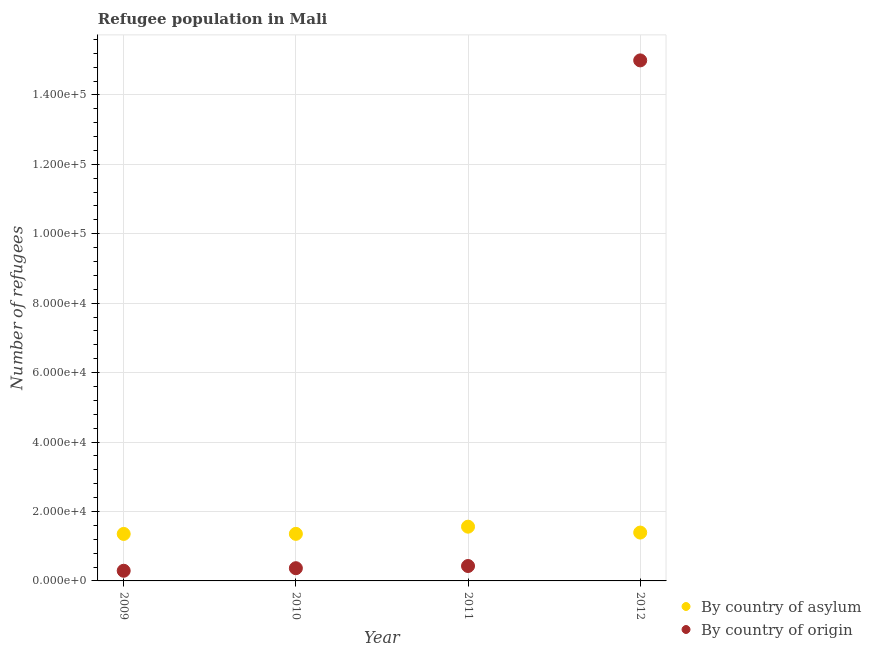How many different coloured dotlines are there?
Your response must be concise. 2. What is the number of refugees by country of asylum in 2010?
Keep it short and to the point. 1.36e+04. Across all years, what is the maximum number of refugees by country of origin?
Ensure brevity in your answer.  1.50e+05. Across all years, what is the minimum number of refugees by country of origin?
Your response must be concise. 2926. In which year was the number of refugees by country of origin maximum?
Provide a succinct answer. 2012. In which year was the number of refugees by country of origin minimum?
Make the answer very short. 2009. What is the total number of refugees by country of origin in the graph?
Provide a short and direct response. 1.61e+05. What is the difference between the number of refugees by country of origin in 2010 and that in 2012?
Keep it short and to the point. -1.46e+05. What is the difference between the number of refugees by country of asylum in 2011 and the number of refugees by country of origin in 2012?
Your answer should be very brief. -1.34e+05. What is the average number of refugees by country of origin per year?
Make the answer very short. 4.02e+04. In the year 2011, what is the difference between the number of refugees by country of origin and number of refugees by country of asylum?
Make the answer very short. -1.13e+04. In how many years, is the number of refugees by country of origin greater than 108000?
Offer a terse response. 1. What is the ratio of the number of refugees by country of asylum in 2009 to that in 2011?
Keep it short and to the point. 0.87. Is the difference between the number of refugees by country of asylum in 2011 and 2012 greater than the difference between the number of refugees by country of origin in 2011 and 2012?
Offer a very short reply. Yes. What is the difference between the highest and the second highest number of refugees by country of asylum?
Give a very brief answer. 1696. What is the difference between the highest and the lowest number of refugees by country of asylum?
Keep it short and to the point. 2086. Is the number of refugees by country of origin strictly less than the number of refugees by country of asylum over the years?
Provide a short and direct response. No. What is the difference between two consecutive major ticks on the Y-axis?
Provide a succinct answer. 2.00e+04. Are the values on the major ticks of Y-axis written in scientific E-notation?
Provide a succinct answer. Yes. Does the graph contain any zero values?
Your answer should be compact. No. Does the graph contain grids?
Ensure brevity in your answer.  Yes. How many legend labels are there?
Your answer should be compact. 2. What is the title of the graph?
Offer a very short reply. Refugee population in Mali. Does "Secondary school" appear as one of the legend labels in the graph?
Your answer should be very brief. No. What is the label or title of the Y-axis?
Ensure brevity in your answer.  Number of refugees. What is the Number of refugees in By country of asylum in 2009?
Your answer should be compact. 1.35e+04. What is the Number of refugees of By country of origin in 2009?
Offer a very short reply. 2926. What is the Number of refugees in By country of asylum in 2010?
Ensure brevity in your answer.  1.36e+04. What is the Number of refugees in By country of origin in 2010?
Your answer should be very brief. 3663. What is the Number of refugees of By country of asylum in 2011?
Offer a terse response. 1.56e+04. What is the Number of refugees in By country of origin in 2011?
Your response must be concise. 4295. What is the Number of refugees in By country of asylum in 2012?
Make the answer very short. 1.39e+04. What is the Number of refugees in By country of origin in 2012?
Provide a succinct answer. 1.50e+05. Across all years, what is the maximum Number of refugees in By country of asylum?
Offer a terse response. 1.56e+04. Across all years, what is the maximum Number of refugees in By country of origin?
Provide a succinct answer. 1.50e+05. Across all years, what is the minimum Number of refugees in By country of asylum?
Your answer should be very brief. 1.35e+04. Across all years, what is the minimum Number of refugees in By country of origin?
Make the answer very short. 2926. What is the total Number of refugees of By country of asylum in the graph?
Keep it short and to the point. 5.66e+04. What is the total Number of refugees of By country of origin in the graph?
Your answer should be compact. 1.61e+05. What is the difference between the Number of refugees of By country of origin in 2009 and that in 2010?
Offer a terse response. -737. What is the difference between the Number of refugees in By country of asylum in 2009 and that in 2011?
Make the answer very short. -2086. What is the difference between the Number of refugees in By country of origin in 2009 and that in 2011?
Your response must be concise. -1369. What is the difference between the Number of refugees of By country of asylum in 2009 and that in 2012?
Your answer should be very brief. -390. What is the difference between the Number of refugees in By country of origin in 2009 and that in 2012?
Make the answer very short. -1.47e+05. What is the difference between the Number of refugees of By country of asylum in 2010 and that in 2011?
Offer a terse response. -2066. What is the difference between the Number of refugees of By country of origin in 2010 and that in 2011?
Give a very brief answer. -632. What is the difference between the Number of refugees in By country of asylum in 2010 and that in 2012?
Keep it short and to the point. -370. What is the difference between the Number of refugees in By country of origin in 2010 and that in 2012?
Provide a short and direct response. -1.46e+05. What is the difference between the Number of refugees of By country of asylum in 2011 and that in 2012?
Make the answer very short. 1696. What is the difference between the Number of refugees of By country of origin in 2011 and that in 2012?
Offer a terse response. -1.46e+05. What is the difference between the Number of refugees of By country of asylum in 2009 and the Number of refugees of By country of origin in 2010?
Offer a terse response. 9875. What is the difference between the Number of refugees in By country of asylum in 2009 and the Number of refugees in By country of origin in 2011?
Provide a succinct answer. 9243. What is the difference between the Number of refugees in By country of asylum in 2009 and the Number of refugees in By country of origin in 2012?
Provide a short and direct response. -1.36e+05. What is the difference between the Number of refugees of By country of asylum in 2010 and the Number of refugees of By country of origin in 2011?
Your response must be concise. 9263. What is the difference between the Number of refugees in By country of asylum in 2010 and the Number of refugees in By country of origin in 2012?
Your answer should be compact. -1.36e+05. What is the difference between the Number of refugees in By country of asylum in 2011 and the Number of refugees in By country of origin in 2012?
Your answer should be compact. -1.34e+05. What is the average Number of refugees of By country of asylum per year?
Offer a terse response. 1.42e+04. What is the average Number of refugees in By country of origin per year?
Offer a very short reply. 4.02e+04. In the year 2009, what is the difference between the Number of refugees in By country of asylum and Number of refugees in By country of origin?
Ensure brevity in your answer.  1.06e+04. In the year 2010, what is the difference between the Number of refugees of By country of asylum and Number of refugees of By country of origin?
Your response must be concise. 9895. In the year 2011, what is the difference between the Number of refugees in By country of asylum and Number of refugees in By country of origin?
Make the answer very short. 1.13e+04. In the year 2012, what is the difference between the Number of refugees in By country of asylum and Number of refugees in By country of origin?
Keep it short and to the point. -1.36e+05. What is the ratio of the Number of refugees of By country of asylum in 2009 to that in 2010?
Offer a very short reply. 1. What is the ratio of the Number of refugees of By country of origin in 2009 to that in 2010?
Your answer should be compact. 0.8. What is the ratio of the Number of refugees in By country of asylum in 2009 to that in 2011?
Your answer should be compact. 0.87. What is the ratio of the Number of refugees of By country of origin in 2009 to that in 2011?
Offer a very short reply. 0.68. What is the ratio of the Number of refugees in By country of origin in 2009 to that in 2012?
Your answer should be very brief. 0.02. What is the ratio of the Number of refugees in By country of asylum in 2010 to that in 2011?
Offer a terse response. 0.87. What is the ratio of the Number of refugees of By country of origin in 2010 to that in 2011?
Your answer should be compact. 0.85. What is the ratio of the Number of refugees in By country of asylum in 2010 to that in 2012?
Make the answer very short. 0.97. What is the ratio of the Number of refugees of By country of origin in 2010 to that in 2012?
Offer a very short reply. 0.02. What is the ratio of the Number of refugees in By country of asylum in 2011 to that in 2012?
Offer a very short reply. 1.12. What is the ratio of the Number of refugees in By country of origin in 2011 to that in 2012?
Your response must be concise. 0.03. What is the difference between the highest and the second highest Number of refugees in By country of asylum?
Offer a very short reply. 1696. What is the difference between the highest and the second highest Number of refugees in By country of origin?
Offer a very short reply. 1.46e+05. What is the difference between the highest and the lowest Number of refugees in By country of asylum?
Provide a succinct answer. 2086. What is the difference between the highest and the lowest Number of refugees of By country of origin?
Your answer should be compact. 1.47e+05. 